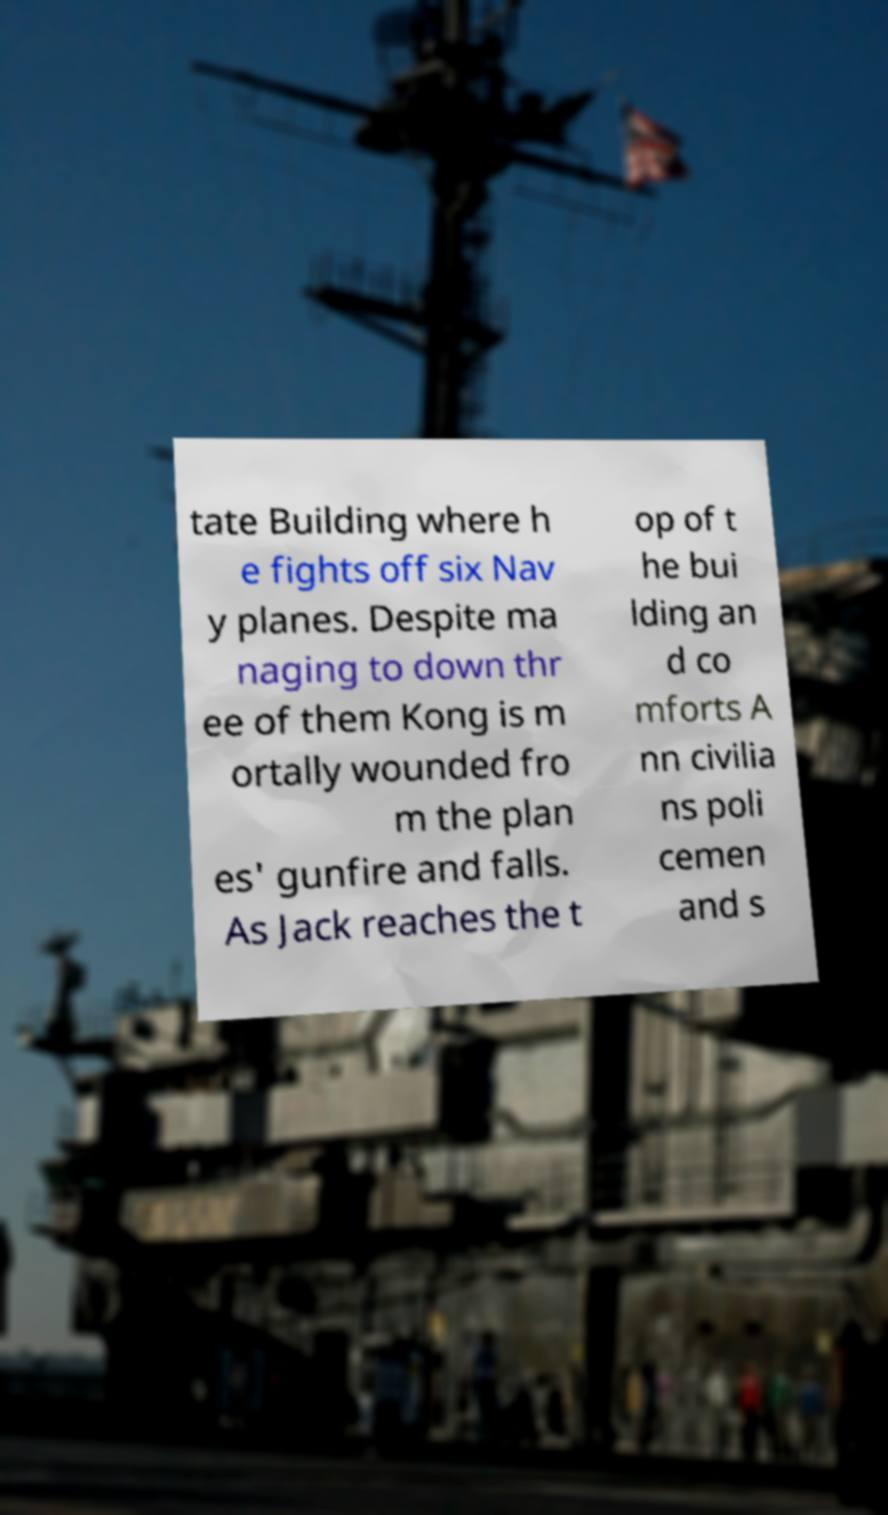Please read and relay the text visible in this image. What does it say? tate Building where h e fights off six Nav y planes. Despite ma naging to down thr ee of them Kong is m ortally wounded fro m the plan es' gunfire and falls. As Jack reaches the t op of t he bui lding an d co mforts A nn civilia ns poli cemen and s 